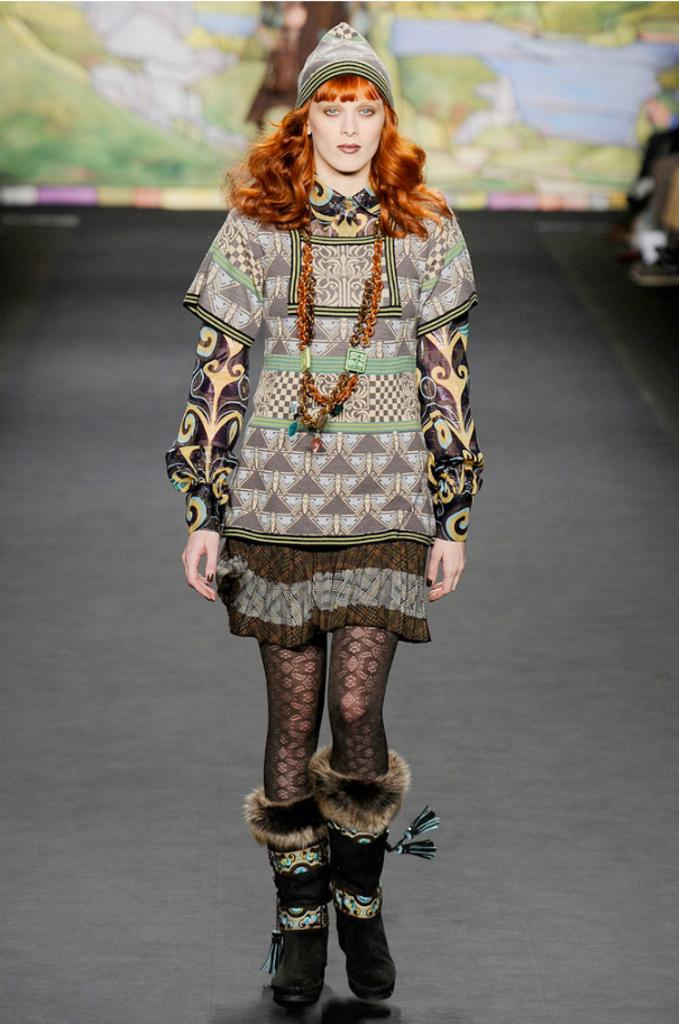Who is the main subject in the image? There is a woman in the image. What is the woman doing in the image? The woman is walking. Can you describe the background of the image? The background of the image is blurry. What type of dolls can be seen in the background of the image? There are no dolls present in the image. What season is it in the image, considering the weather or clothing? The provided facts do not give any information about the weather or clothing, so it is not possible to determine the season from the image. 